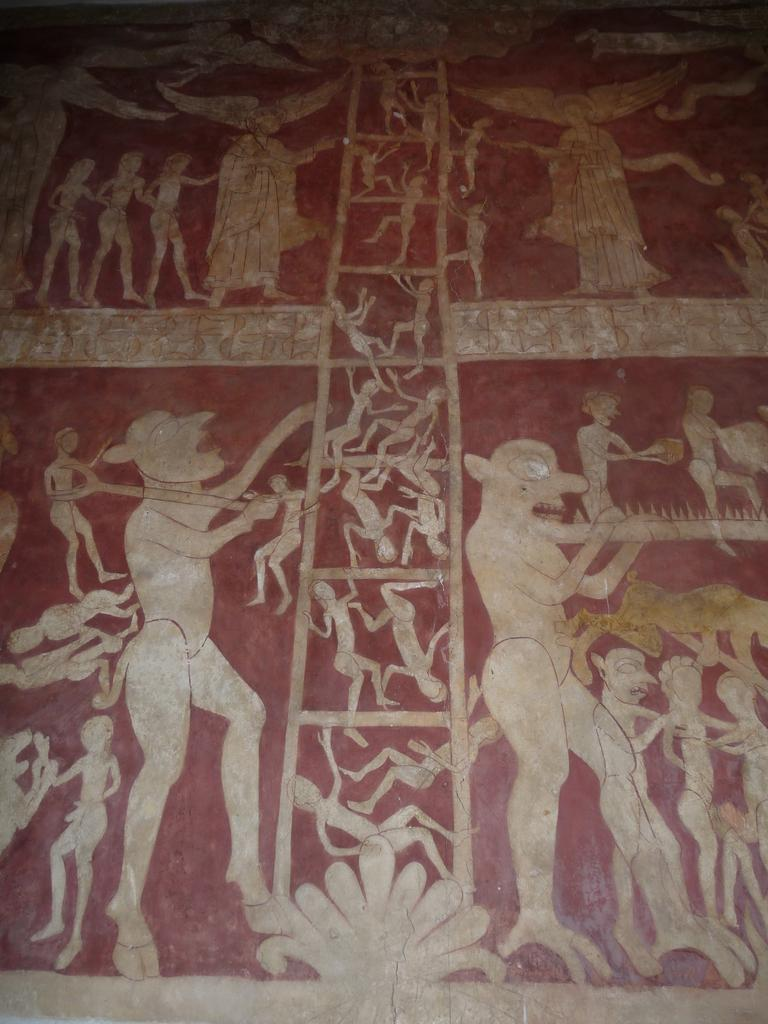What is present on the wall in the image? The wall has paintings on it. Can you describe the paintings on the wall? Unfortunately, the provided facts do not include a description of the paintings. What is the primary purpose of the wall in the image? The primary purpose of the wall is to support the paintings. What type of yarn is used to create the paintings on the wall? There is no yarn present in the image, as the paintings are not created with yarn. 